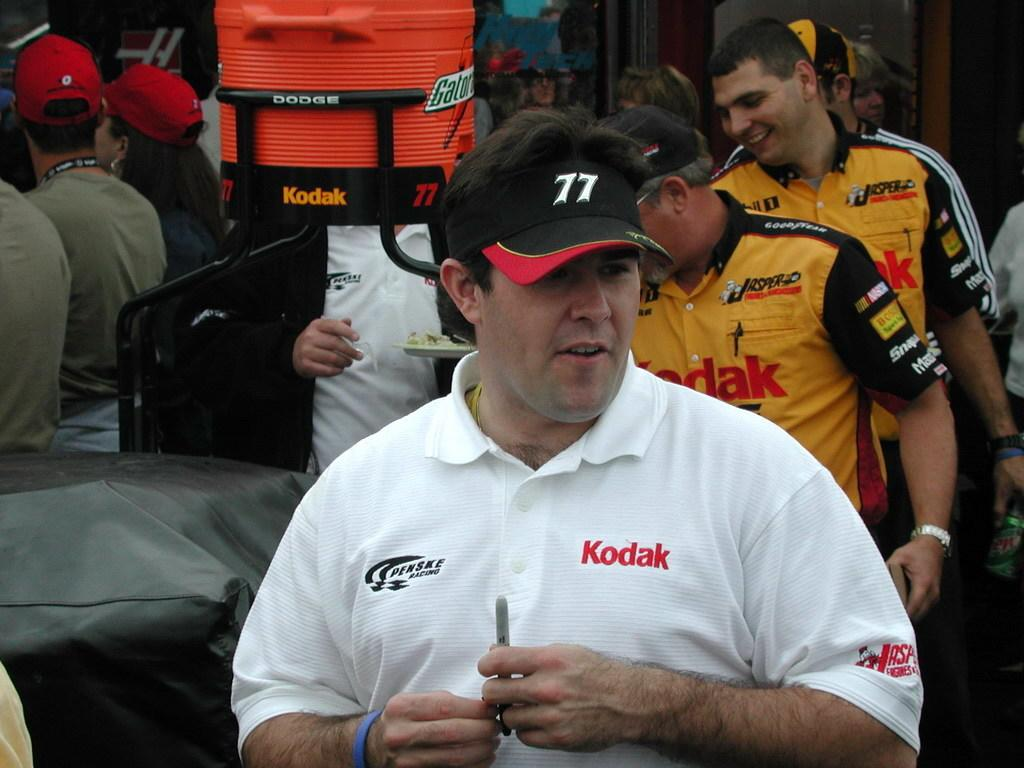<image>
Provide a brief description of the given image. A man standing in front of other men and has the word Kodak on his shirt. 